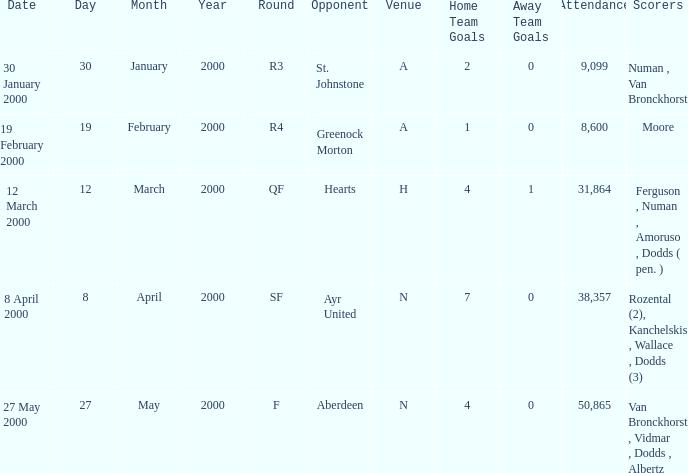Who existed on march 12, 2000? Ferguson , Numan , Amoruso , Dodds ( pen. ). 